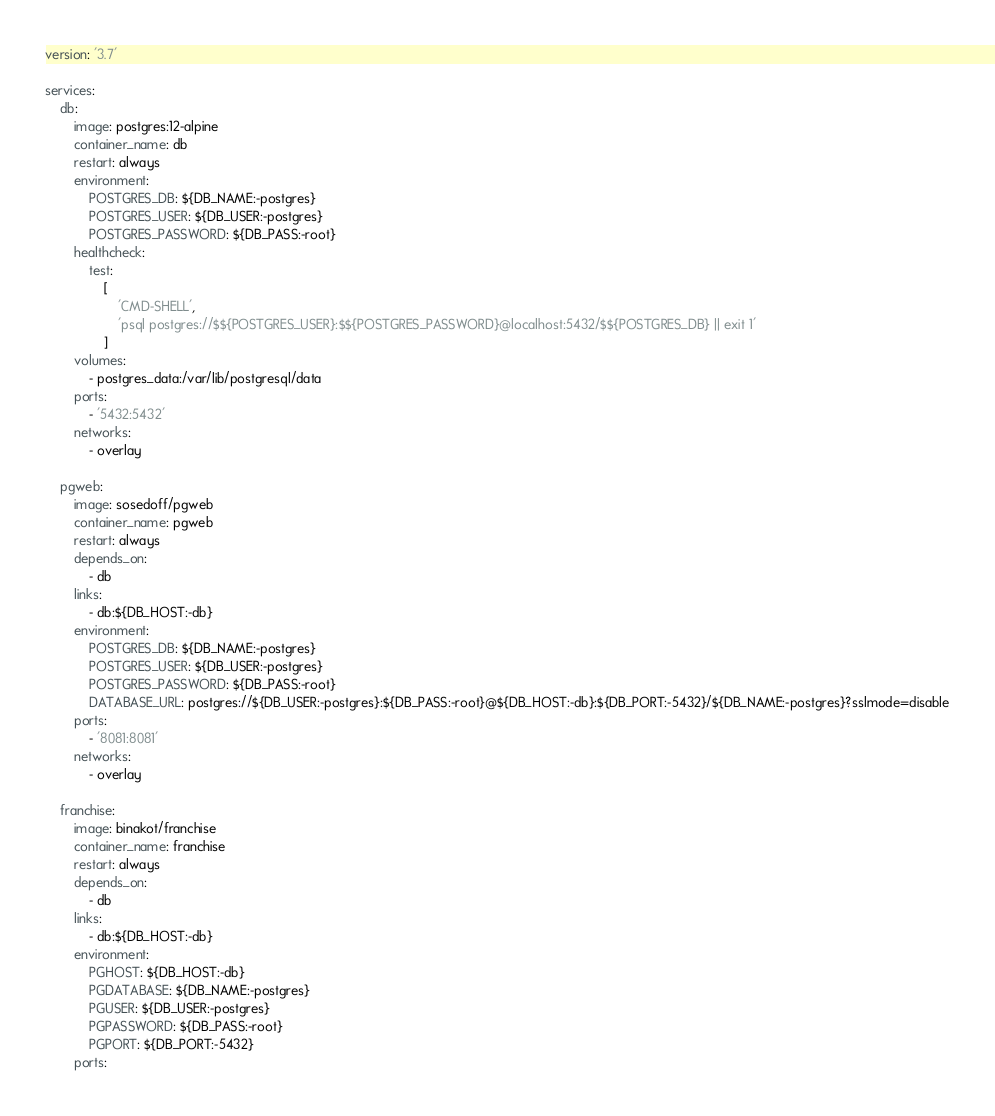<code> <loc_0><loc_0><loc_500><loc_500><_YAML_>version: '3.7'

services:
    db:
        image: postgres:12-alpine
        container_name: db
        restart: always
        environment:
            POSTGRES_DB: ${DB_NAME:-postgres}
            POSTGRES_USER: ${DB_USER:-postgres}
            POSTGRES_PASSWORD: ${DB_PASS:-root}
        healthcheck:
            test:
                [
                    'CMD-SHELL',
                    'psql postgres://$${POSTGRES_USER}:$${POSTGRES_PASSWORD}@localhost:5432/$${POSTGRES_DB} || exit 1'
                ]
        volumes:
            - postgres_data:/var/lib/postgresql/data
        ports:
            - '5432:5432'
        networks:
            - overlay

    pgweb:
        image: sosedoff/pgweb
        container_name: pgweb
        restart: always
        depends_on:
            - db
        links:
            - db:${DB_HOST:-db}
        environment:
            POSTGRES_DB: ${DB_NAME:-postgres}
            POSTGRES_USER: ${DB_USER:-postgres}
            POSTGRES_PASSWORD: ${DB_PASS:-root}
            DATABASE_URL: postgres://${DB_USER:-postgres}:${DB_PASS:-root}@${DB_HOST:-db}:${DB_PORT:-5432}/${DB_NAME:-postgres}?sslmode=disable
        ports:
            - '8081:8081'
        networks:
            - overlay

    franchise:
        image: binakot/franchise
        container_name: franchise
        restart: always
        depends_on:
            - db
        links:
            - db:${DB_HOST:-db}
        environment:
            PGHOST: ${DB_HOST:-db}
            PGDATABASE: ${DB_NAME:-postgres}
            PGUSER: ${DB_USER:-postgres}
            PGPASSWORD: ${DB_PASS:-root}
            PGPORT: ${DB_PORT:-5432}
        ports:</code> 